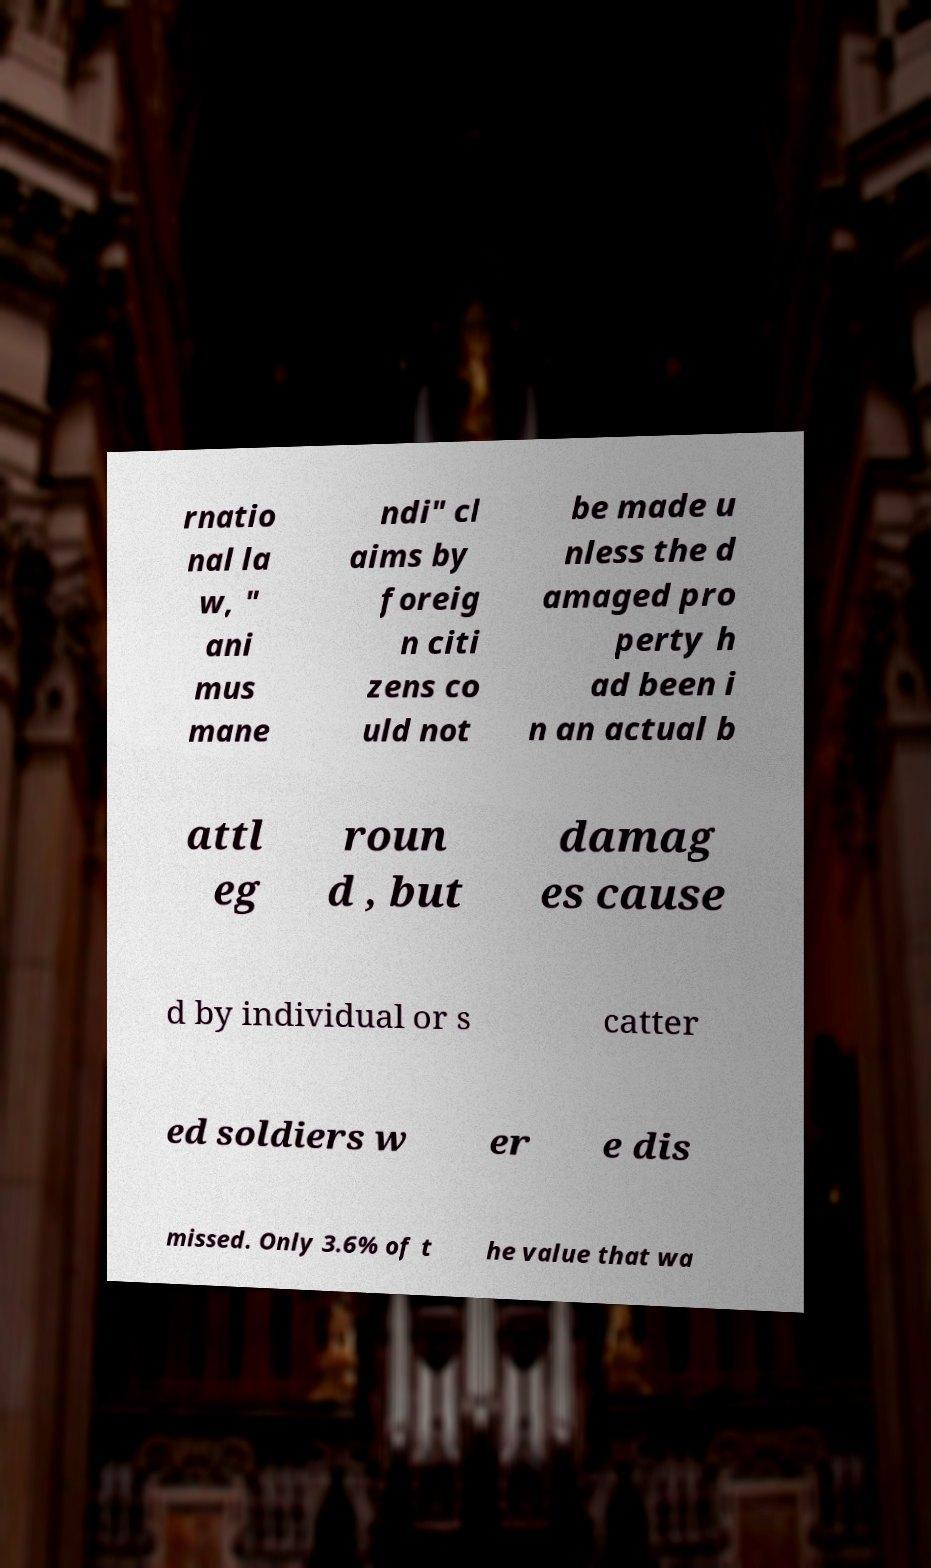For documentation purposes, I need the text within this image transcribed. Could you provide that? rnatio nal la w, " ani mus mane ndi" cl aims by foreig n citi zens co uld not be made u nless the d amaged pro perty h ad been i n an actual b attl eg roun d , but damag es cause d by individual or s catter ed soldiers w er e dis missed. Only 3.6% of t he value that wa 